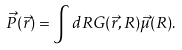<formula> <loc_0><loc_0><loc_500><loc_500>\vec { P } ( \vec { r } ) = \int { d R } G ( \vec { r } , R ) \vec { \mu } ( R ) .</formula> 